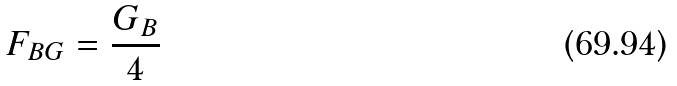<formula> <loc_0><loc_0><loc_500><loc_500>F _ { B G } = \frac { G _ { B } } { 4 }</formula> 